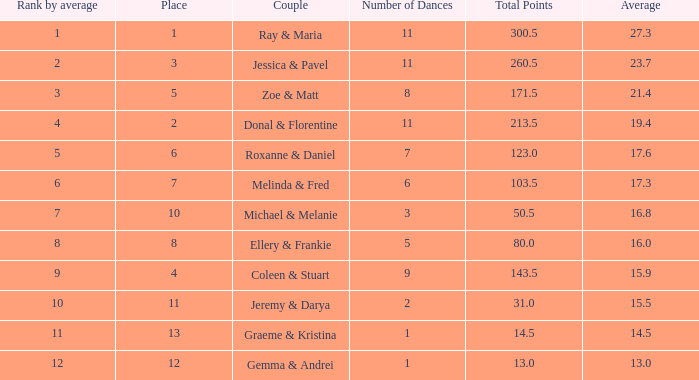0? 1.0. 